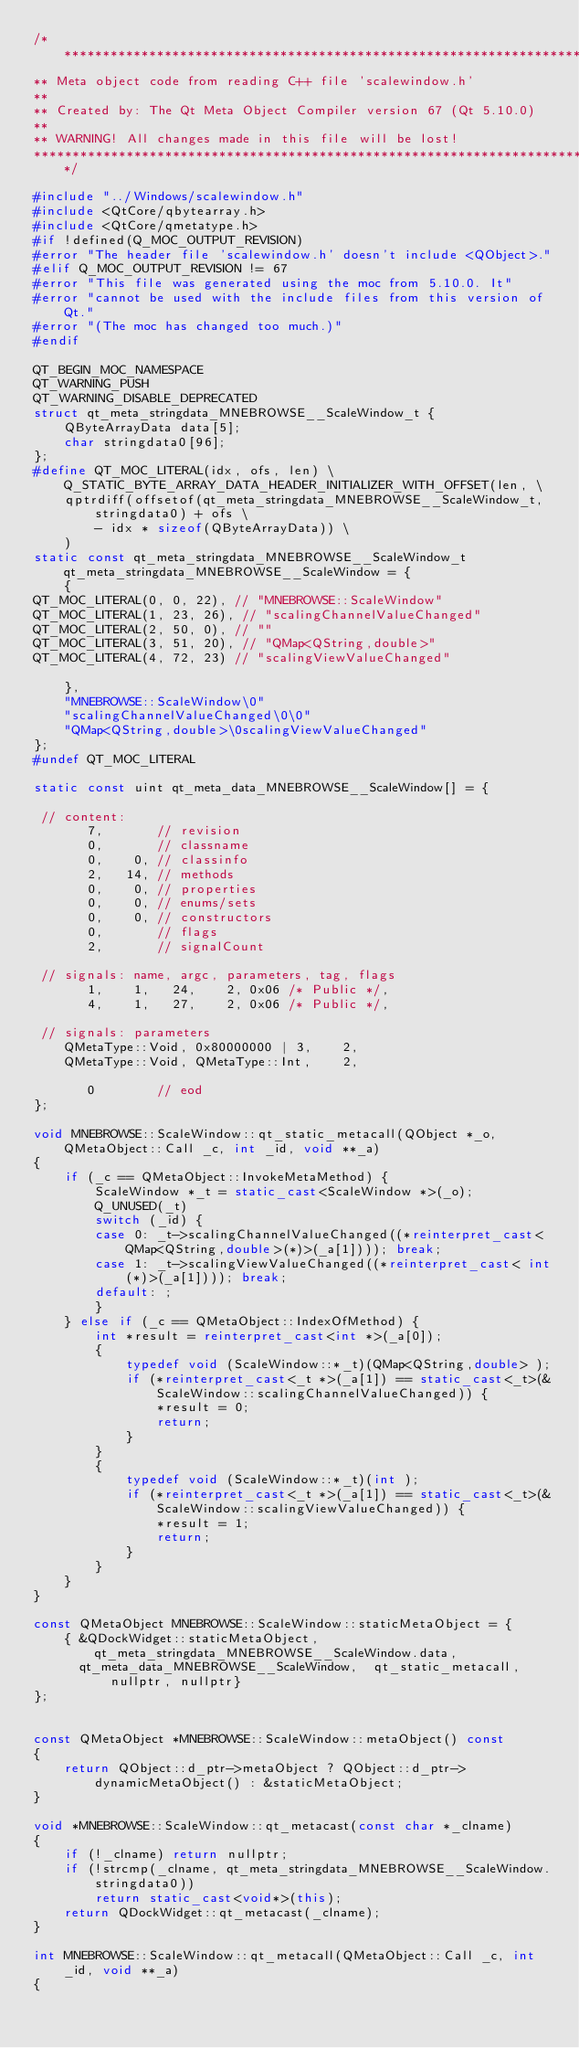Convert code to text. <code><loc_0><loc_0><loc_500><loc_500><_C++_>/****************************************************************************
** Meta object code from reading C++ file 'scalewindow.h'
**
** Created by: The Qt Meta Object Compiler version 67 (Qt 5.10.0)
**
** WARNING! All changes made in this file will be lost!
*****************************************************************************/

#include "../Windows/scalewindow.h"
#include <QtCore/qbytearray.h>
#include <QtCore/qmetatype.h>
#if !defined(Q_MOC_OUTPUT_REVISION)
#error "The header file 'scalewindow.h' doesn't include <QObject>."
#elif Q_MOC_OUTPUT_REVISION != 67
#error "This file was generated using the moc from 5.10.0. It"
#error "cannot be used with the include files from this version of Qt."
#error "(The moc has changed too much.)"
#endif

QT_BEGIN_MOC_NAMESPACE
QT_WARNING_PUSH
QT_WARNING_DISABLE_DEPRECATED
struct qt_meta_stringdata_MNEBROWSE__ScaleWindow_t {
    QByteArrayData data[5];
    char stringdata0[96];
};
#define QT_MOC_LITERAL(idx, ofs, len) \
    Q_STATIC_BYTE_ARRAY_DATA_HEADER_INITIALIZER_WITH_OFFSET(len, \
    qptrdiff(offsetof(qt_meta_stringdata_MNEBROWSE__ScaleWindow_t, stringdata0) + ofs \
        - idx * sizeof(QByteArrayData)) \
    )
static const qt_meta_stringdata_MNEBROWSE__ScaleWindow_t qt_meta_stringdata_MNEBROWSE__ScaleWindow = {
    {
QT_MOC_LITERAL(0, 0, 22), // "MNEBROWSE::ScaleWindow"
QT_MOC_LITERAL(1, 23, 26), // "scalingChannelValueChanged"
QT_MOC_LITERAL(2, 50, 0), // ""
QT_MOC_LITERAL(3, 51, 20), // "QMap<QString,double>"
QT_MOC_LITERAL(4, 72, 23) // "scalingViewValueChanged"

    },
    "MNEBROWSE::ScaleWindow\0"
    "scalingChannelValueChanged\0\0"
    "QMap<QString,double>\0scalingViewValueChanged"
};
#undef QT_MOC_LITERAL

static const uint qt_meta_data_MNEBROWSE__ScaleWindow[] = {

 // content:
       7,       // revision
       0,       // classname
       0,    0, // classinfo
       2,   14, // methods
       0,    0, // properties
       0,    0, // enums/sets
       0,    0, // constructors
       0,       // flags
       2,       // signalCount

 // signals: name, argc, parameters, tag, flags
       1,    1,   24,    2, 0x06 /* Public */,
       4,    1,   27,    2, 0x06 /* Public */,

 // signals: parameters
    QMetaType::Void, 0x80000000 | 3,    2,
    QMetaType::Void, QMetaType::Int,    2,

       0        // eod
};

void MNEBROWSE::ScaleWindow::qt_static_metacall(QObject *_o, QMetaObject::Call _c, int _id, void **_a)
{
    if (_c == QMetaObject::InvokeMetaMethod) {
        ScaleWindow *_t = static_cast<ScaleWindow *>(_o);
        Q_UNUSED(_t)
        switch (_id) {
        case 0: _t->scalingChannelValueChanged((*reinterpret_cast< QMap<QString,double>(*)>(_a[1]))); break;
        case 1: _t->scalingViewValueChanged((*reinterpret_cast< int(*)>(_a[1]))); break;
        default: ;
        }
    } else if (_c == QMetaObject::IndexOfMethod) {
        int *result = reinterpret_cast<int *>(_a[0]);
        {
            typedef void (ScaleWindow::*_t)(QMap<QString,double> );
            if (*reinterpret_cast<_t *>(_a[1]) == static_cast<_t>(&ScaleWindow::scalingChannelValueChanged)) {
                *result = 0;
                return;
            }
        }
        {
            typedef void (ScaleWindow::*_t)(int );
            if (*reinterpret_cast<_t *>(_a[1]) == static_cast<_t>(&ScaleWindow::scalingViewValueChanged)) {
                *result = 1;
                return;
            }
        }
    }
}

const QMetaObject MNEBROWSE::ScaleWindow::staticMetaObject = {
    { &QDockWidget::staticMetaObject, qt_meta_stringdata_MNEBROWSE__ScaleWindow.data,
      qt_meta_data_MNEBROWSE__ScaleWindow,  qt_static_metacall, nullptr, nullptr}
};


const QMetaObject *MNEBROWSE::ScaleWindow::metaObject() const
{
    return QObject::d_ptr->metaObject ? QObject::d_ptr->dynamicMetaObject() : &staticMetaObject;
}

void *MNEBROWSE::ScaleWindow::qt_metacast(const char *_clname)
{
    if (!_clname) return nullptr;
    if (!strcmp(_clname, qt_meta_stringdata_MNEBROWSE__ScaleWindow.stringdata0))
        return static_cast<void*>(this);
    return QDockWidget::qt_metacast(_clname);
}

int MNEBROWSE::ScaleWindow::qt_metacall(QMetaObject::Call _c, int _id, void **_a)
{</code> 